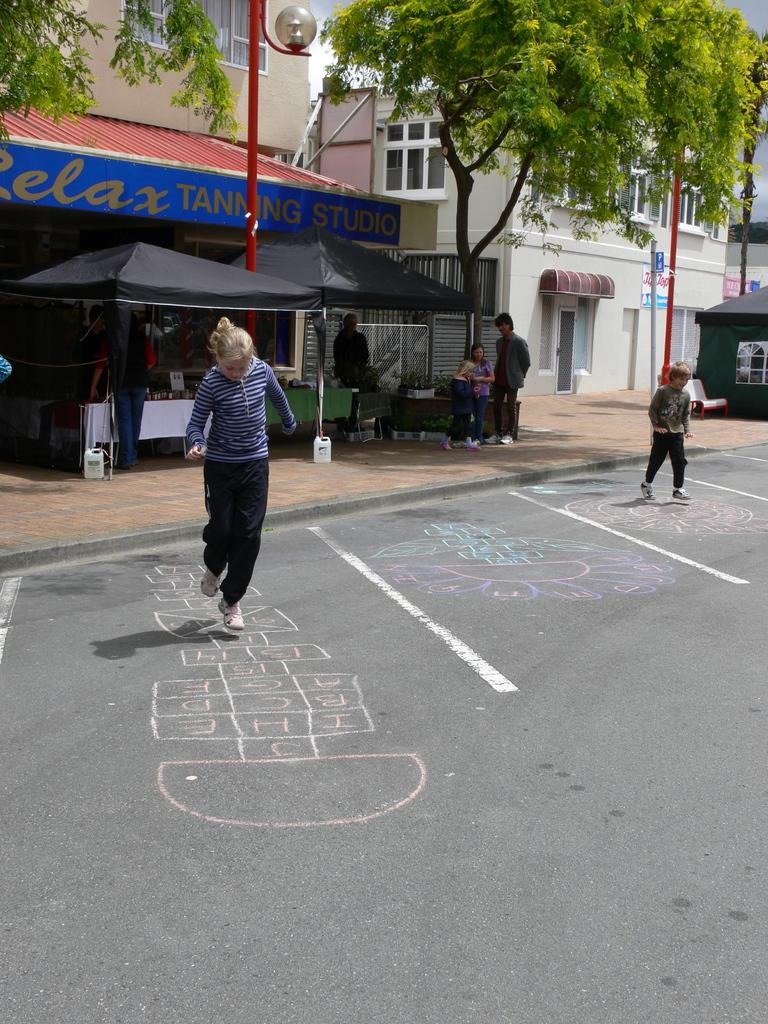What is the girl in the image doing? The girl is playing on the road. What type of establishment can be seen in the image? There is a store in the image. What color is the tree in the image? The tree in the image is green. What structure is located on the right side of the image? There is a house on the right side of the image. What type of pen is the girl using to draw on the road? There is no pen present in the image, and the girl is playing, not drawing. 